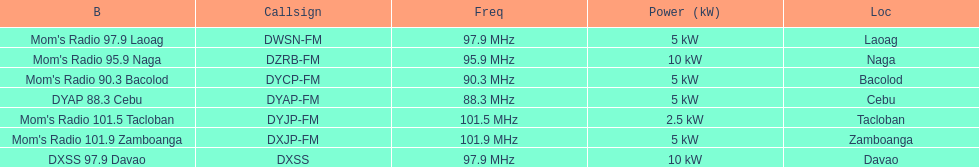What is the total number of stations with frequencies above 100 mhz? 2. 